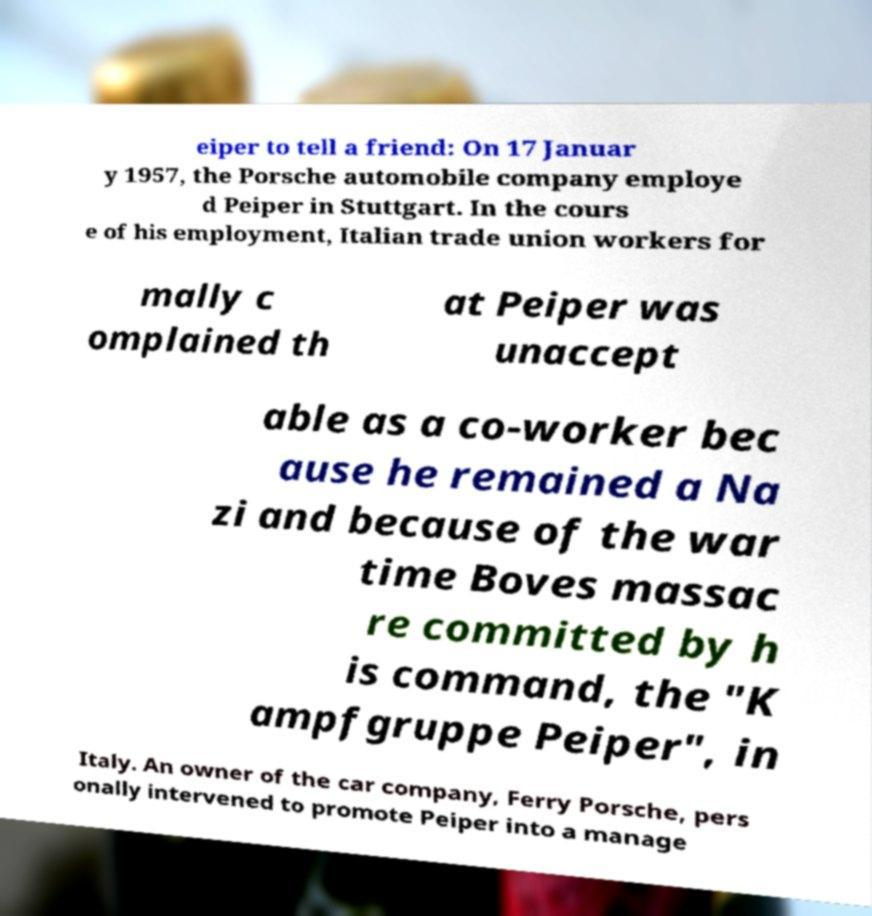There's text embedded in this image that I need extracted. Can you transcribe it verbatim? eiper to tell a friend: On 17 Januar y 1957, the Porsche automobile company employe d Peiper in Stuttgart. In the cours e of his employment, Italian trade union workers for mally c omplained th at Peiper was unaccept able as a co-worker bec ause he remained a Na zi and because of the war time Boves massac re committed by h is command, the "K ampfgruppe Peiper", in Italy. An owner of the car company, Ferry Porsche, pers onally intervened to promote Peiper into a manage 